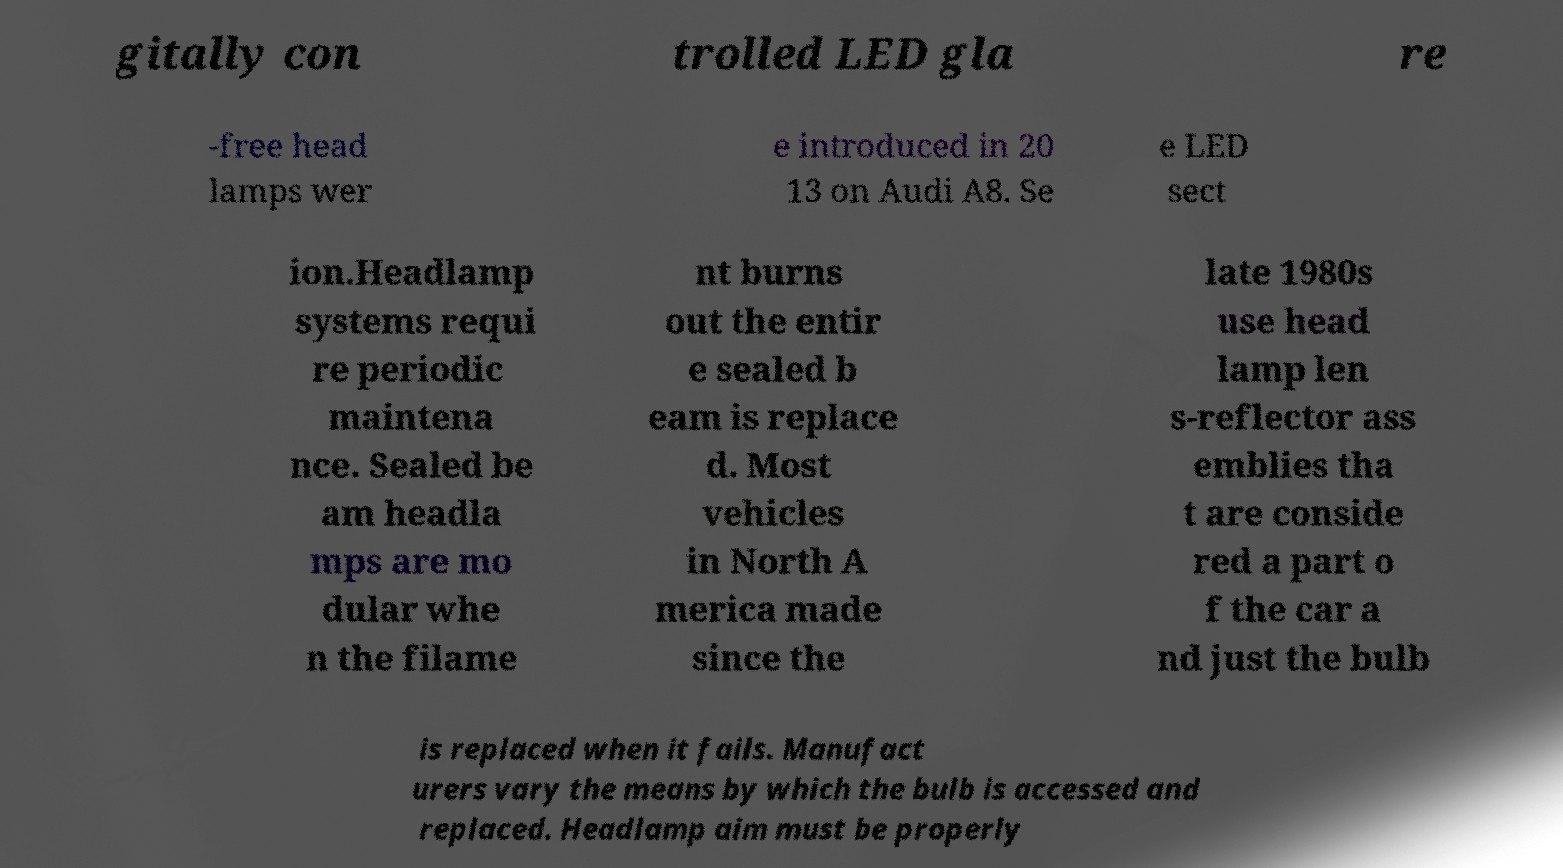Could you extract and type out the text from this image? gitally con trolled LED gla re -free head lamps wer e introduced in 20 13 on Audi A8. Se e LED sect ion.Headlamp systems requi re periodic maintena nce. Sealed be am headla mps are mo dular whe n the filame nt burns out the entir e sealed b eam is replace d. Most vehicles in North A merica made since the late 1980s use head lamp len s-reflector ass emblies tha t are conside red a part o f the car a nd just the bulb is replaced when it fails. Manufact urers vary the means by which the bulb is accessed and replaced. Headlamp aim must be properly 